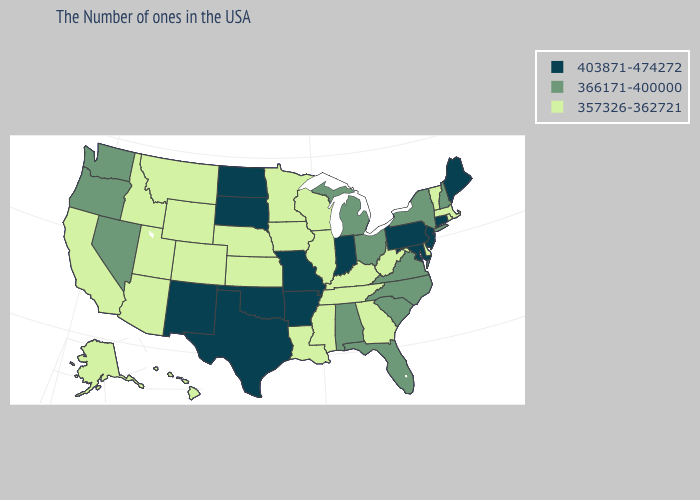Name the states that have a value in the range 366171-400000?
Write a very short answer. New Hampshire, New York, Virginia, North Carolina, South Carolina, Ohio, Florida, Michigan, Alabama, Nevada, Washington, Oregon. Name the states that have a value in the range 403871-474272?
Answer briefly. Maine, Connecticut, New Jersey, Maryland, Pennsylvania, Indiana, Missouri, Arkansas, Oklahoma, Texas, South Dakota, North Dakota, New Mexico. What is the value of Washington?
Answer briefly. 366171-400000. What is the highest value in the MidWest ?
Answer briefly. 403871-474272. Name the states that have a value in the range 366171-400000?
Short answer required. New Hampshire, New York, Virginia, North Carolina, South Carolina, Ohio, Florida, Michigan, Alabama, Nevada, Washington, Oregon. Among the states that border Arkansas , does Texas have the highest value?
Be succinct. Yes. Does the map have missing data?
Answer briefly. No. What is the lowest value in the USA?
Give a very brief answer. 357326-362721. What is the highest value in the South ?
Give a very brief answer. 403871-474272. Does Maryland have the lowest value in the USA?
Concise answer only. No. What is the highest value in states that border Montana?
Give a very brief answer. 403871-474272. Name the states that have a value in the range 357326-362721?
Short answer required. Massachusetts, Rhode Island, Vermont, Delaware, West Virginia, Georgia, Kentucky, Tennessee, Wisconsin, Illinois, Mississippi, Louisiana, Minnesota, Iowa, Kansas, Nebraska, Wyoming, Colorado, Utah, Montana, Arizona, Idaho, California, Alaska, Hawaii. What is the value of Wisconsin?
Concise answer only. 357326-362721. Name the states that have a value in the range 366171-400000?
Write a very short answer. New Hampshire, New York, Virginia, North Carolina, South Carolina, Ohio, Florida, Michigan, Alabama, Nevada, Washington, Oregon. Which states hav the highest value in the Northeast?
Give a very brief answer. Maine, Connecticut, New Jersey, Pennsylvania. 